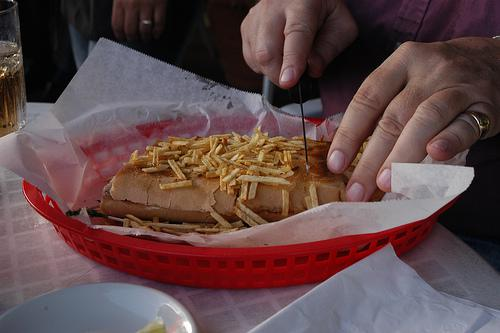Question: why does the person have a knife?
Choices:
A. To stab the sandwich.
B. To kill the sandwich.
C. To cut the sandwich.
D. To cut his hair.
Answer with the letter. Answer: C Question: how many rings is the person wearing?
Choices:
A. One.
B. Two.
C. Ten.
D. Three.
Answer with the letter. Answer: A Question: what is on top of the sandwich?
Choices:
A. Hair.
B. Pickles.
C. Fries.
D. Onions.
Answer with the letter. Answer: C 